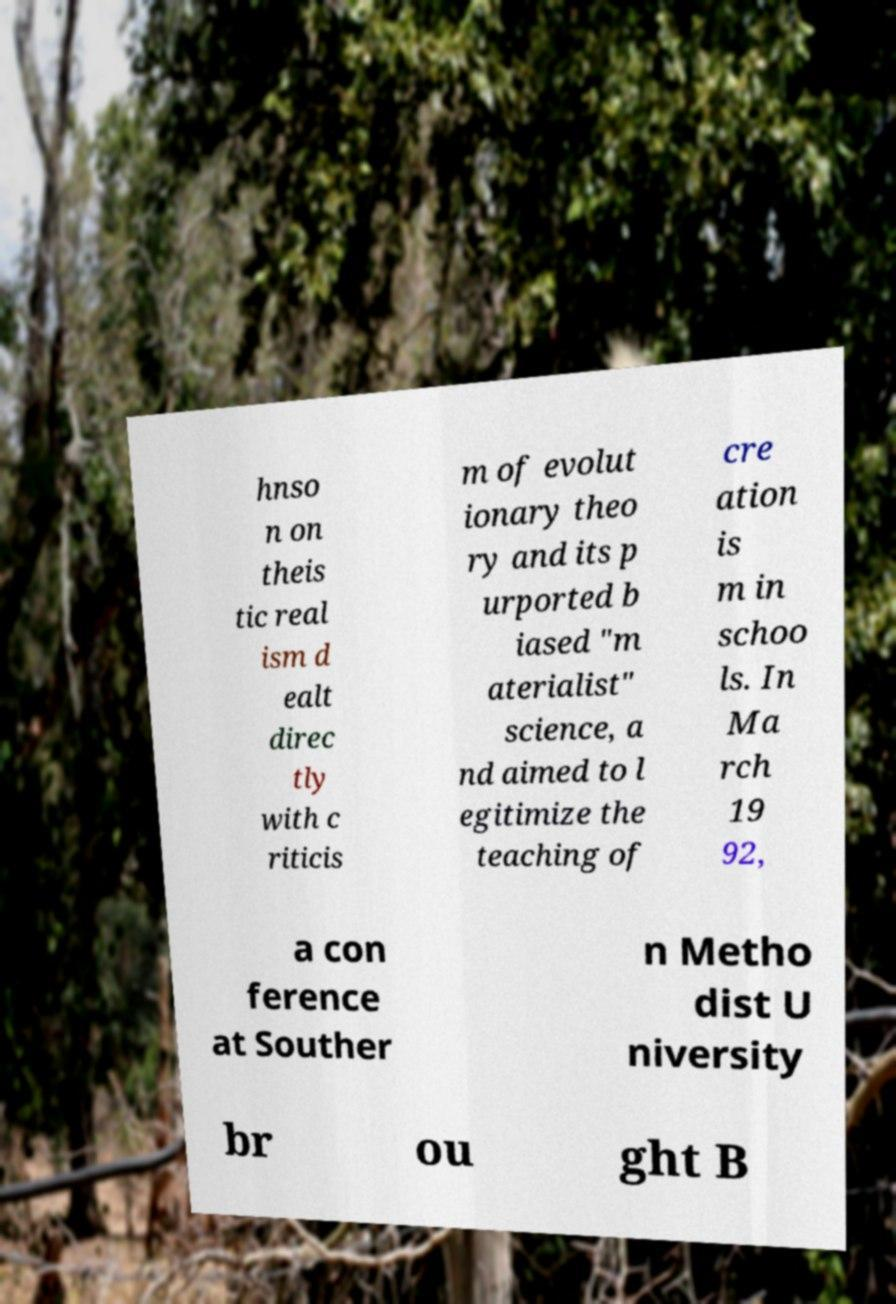Please read and relay the text visible in this image. What does it say? hnso n on theis tic real ism d ealt direc tly with c riticis m of evolut ionary theo ry and its p urported b iased "m aterialist" science, a nd aimed to l egitimize the teaching of cre ation is m in schoo ls. In Ma rch 19 92, a con ference at Souther n Metho dist U niversity br ou ght B 